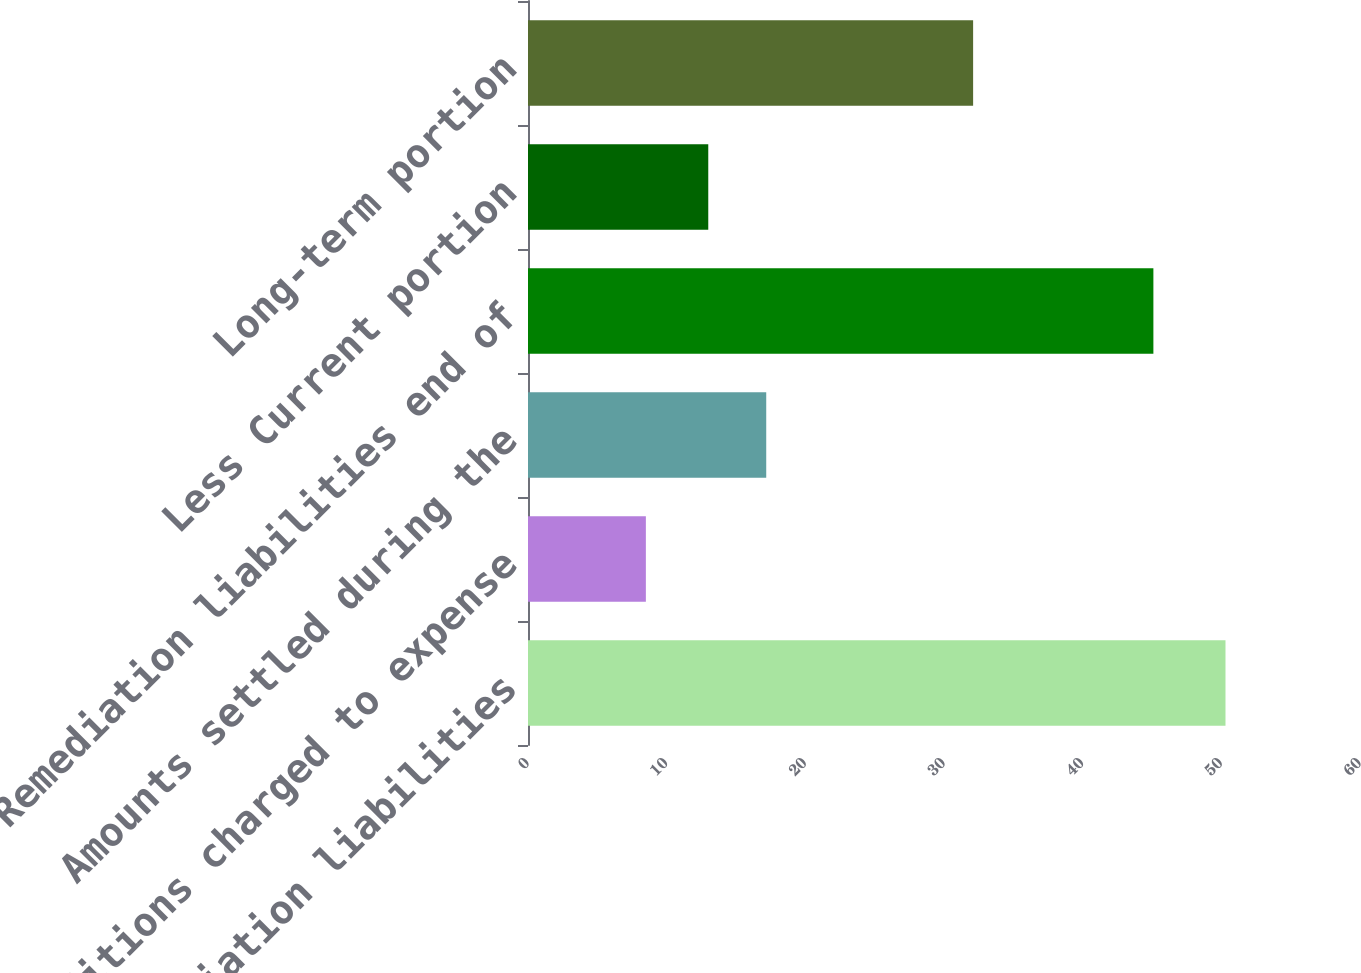Convert chart to OTSL. <chart><loc_0><loc_0><loc_500><loc_500><bar_chart><fcel>Remediation liabilities<fcel>Additions charged to expense<fcel>Amounts settled during the<fcel>Remediation liabilities end of<fcel>Less Current portion<fcel>Long-term portion<nl><fcel>50.3<fcel>8.5<fcel>17.18<fcel>45.1<fcel>13<fcel>32.1<nl></chart> 